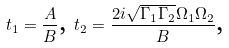<formula> <loc_0><loc_0><loc_500><loc_500>t _ { 1 } = \frac { A } { B } \text {, } t _ { 2 } = \frac { 2 i \sqrt { \Gamma _ { 1 } \Gamma _ { 2 } } \Omega _ { 1 } \Omega _ { 2 } } { B } \text {,}</formula> 